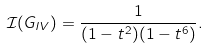<formula> <loc_0><loc_0><loc_500><loc_500>\mathcal { I } ( G _ { I V } ) = \frac { 1 } { ( 1 - t ^ { 2 } ) ( 1 - t ^ { 6 } ) } .</formula> 